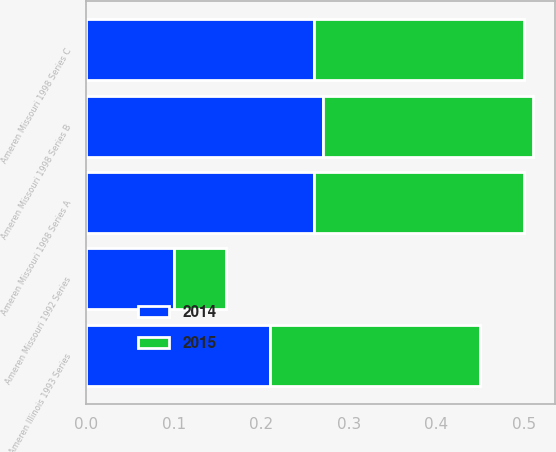Convert chart to OTSL. <chart><loc_0><loc_0><loc_500><loc_500><stacked_bar_chart><ecel><fcel>Ameren Missouri 1992 Series<fcel>Ameren Missouri 1998 Series A<fcel>Ameren Missouri 1998 Series B<fcel>Ameren Missouri 1998 Series C<fcel>Ameren Illinois 1993 Series<nl><fcel>2015<fcel>0.06<fcel>0.24<fcel>0.24<fcel>0.24<fcel>0.24<nl><fcel>2014<fcel>0.1<fcel>0.26<fcel>0.27<fcel>0.26<fcel>0.21<nl></chart> 